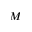Convert formula to latex. <formula><loc_0><loc_0><loc_500><loc_500>M</formula> 